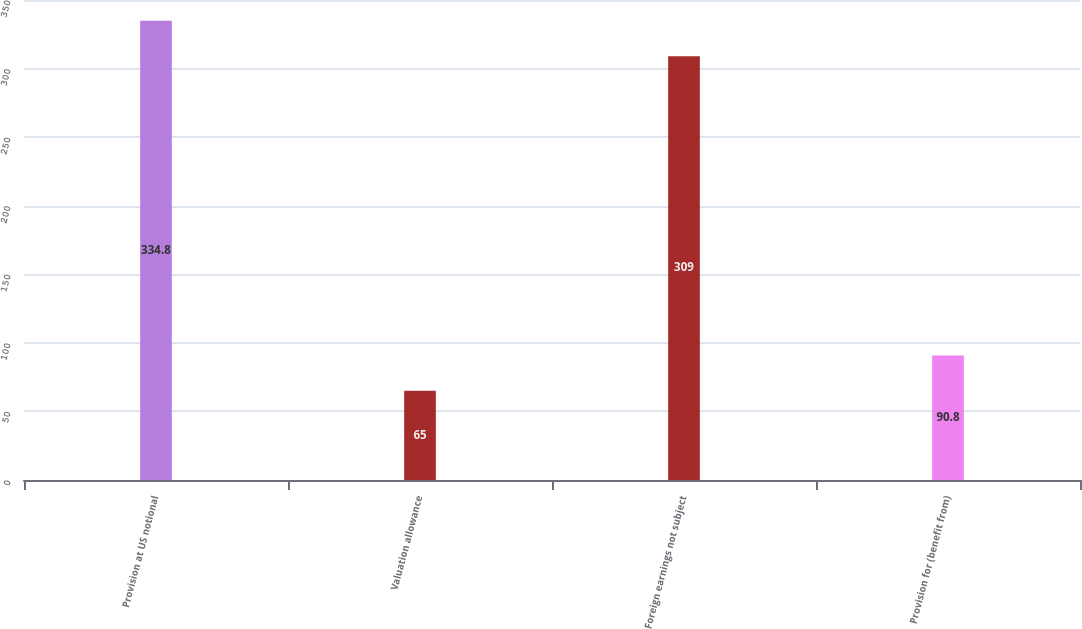Convert chart. <chart><loc_0><loc_0><loc_500><loc_500><bar_chart><fcel>Provision at US notional<fcel>Valuation allowance<fcel>Foreign earnings not subject<fcel>Provision for (benefit from)<nl><fcel>334.8<fcel>65<fcel>309<fcel>90.8<nl></chart> 